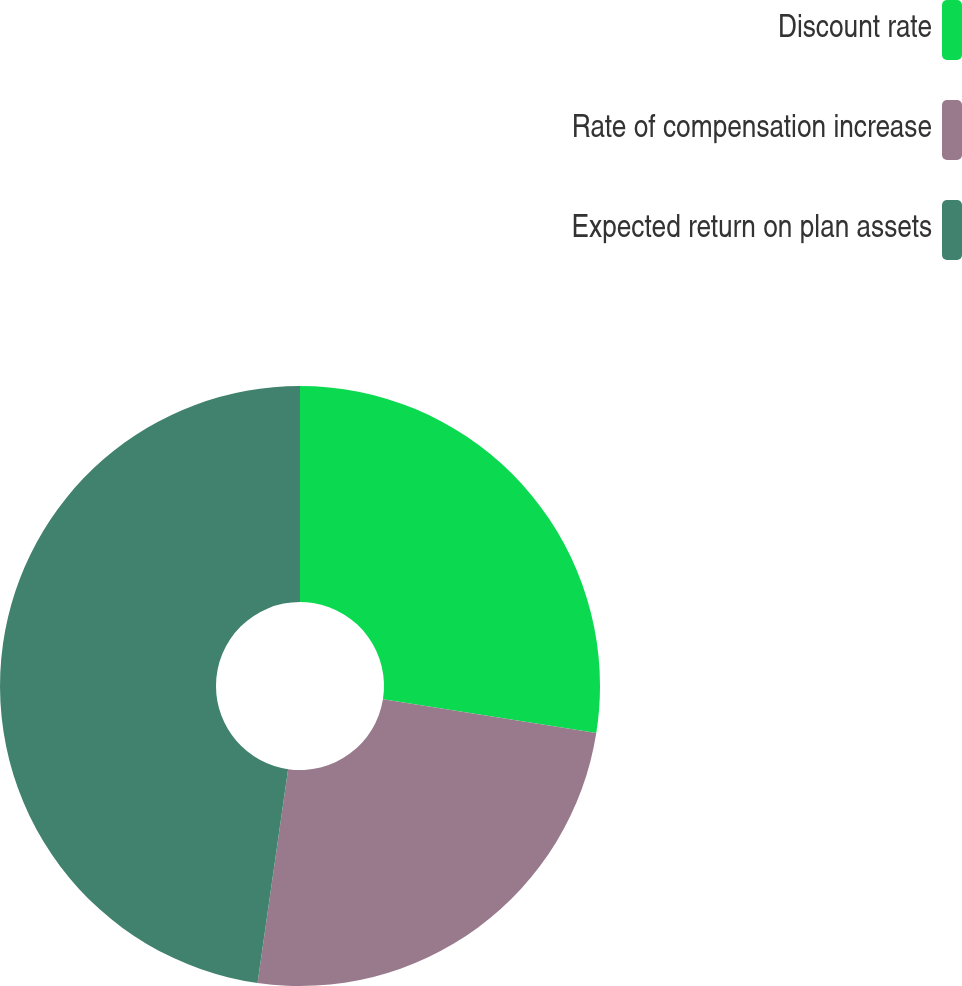Convert chart to OTSL. <chart><loc_0><loc_0><loc_500><loc_500><pie_chart><fcel>Discount rate<fcel>Rate of compensation increase<fcel>Expected return on plan assets<nl><fcel>27.51%<fcel>24.75%<fcel>47.74%<nl></chart> 